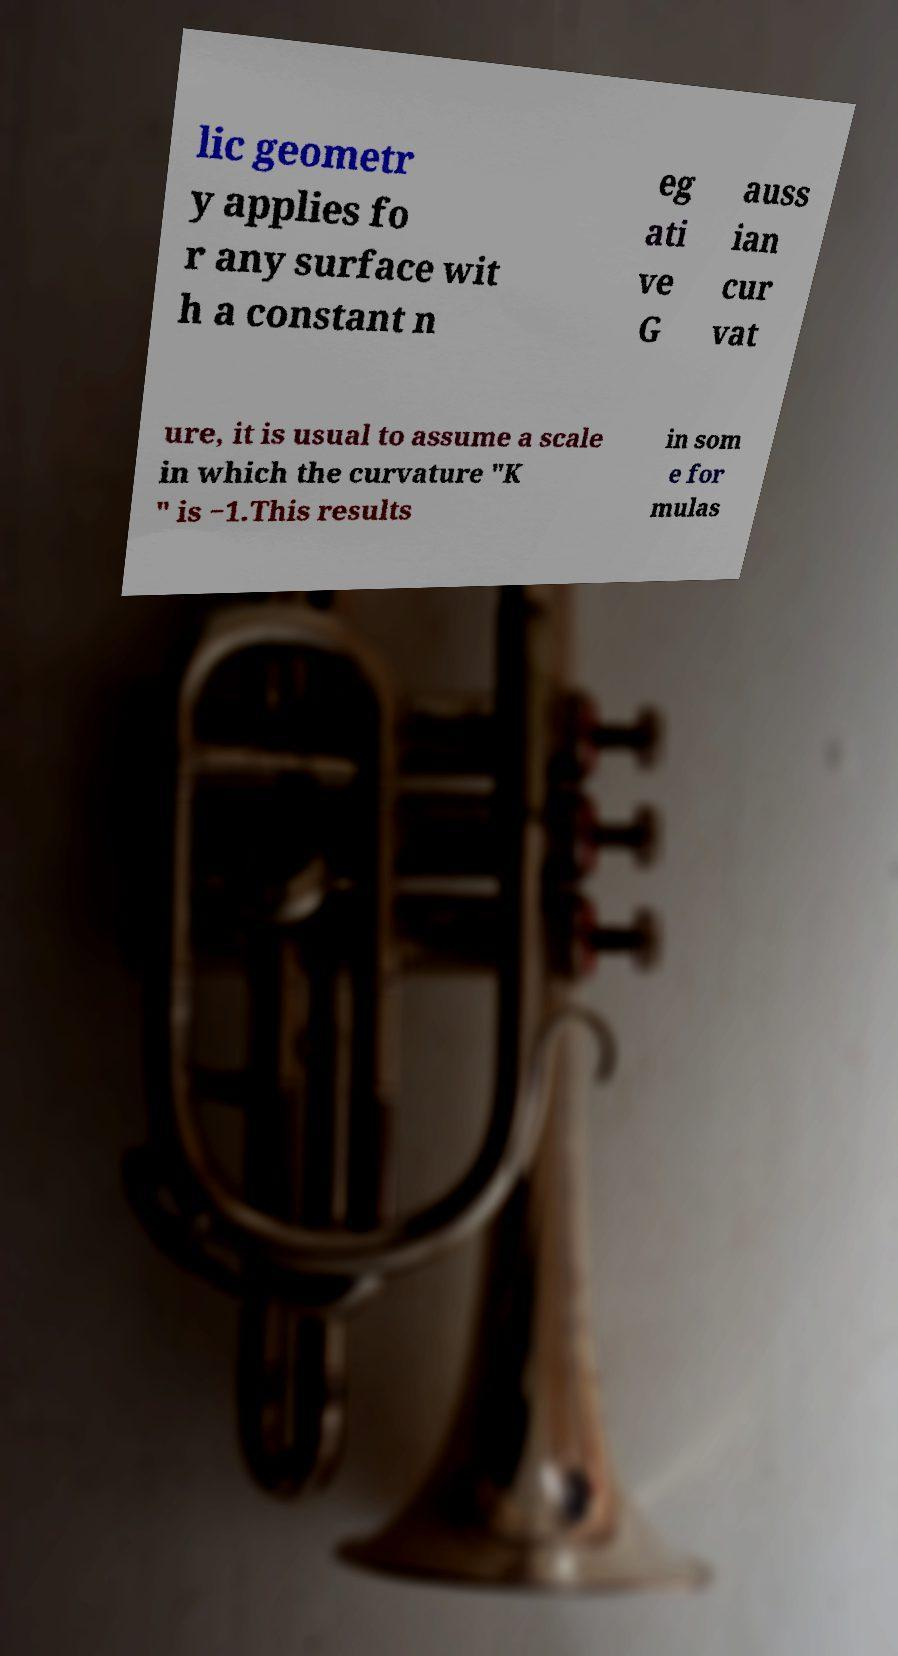I need the written content from this picture converted into text. Can you do that? lic geometr y applies fo r any surface wit h a constant n eg ati ve G auss ian cur vat ure, it is usual to assume a scale in which the curvature "K " is −1.This results in som e for mulas 